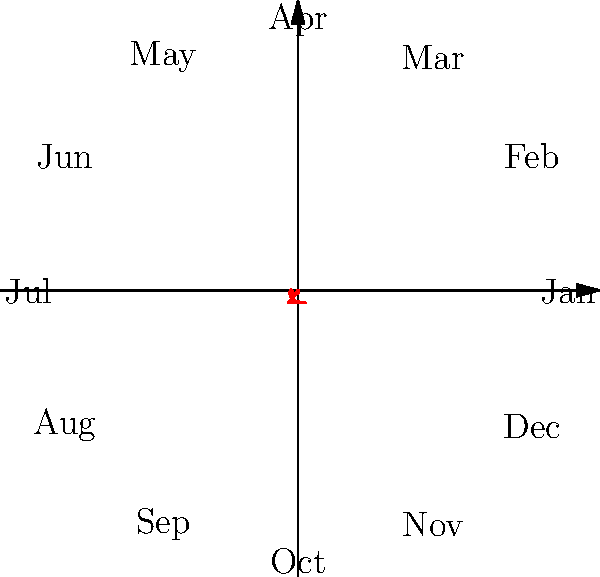The polar rose diagram above represents community event attendance over a year. Which month had the highest attendance, and what strategy might you recommend to replicate this success for other months? To answer this question, we need to analyze the polar rose diagram:

1. The diagram represents community event attendance over 12 months.
2. Each month is represented by a radial line, with the distance from the center indicating attendance numbers.
3. To find the month with the highest attendance, we look for the longest radial line.
4. Observing the diagram, we can see that the longest line points towards the label "Jun", representing June.
5. June has the highest peak, indicating the highest attendance of all months.

Strategies to replicate this success:

1. Analyze the June event: Investigate what made the June event so successful (e.g., type of event, marketing strategies, timing).
2. Seasonal considerations: June often has favorable weather conditions. Consider how to adapt events for other seasons.
3. Community engagement: Reach out to attendees of the June event to understand what attracted them and how to improve future events.
4. Targeted outreach: Use the success of the June event to promote similar events to the same demographic groups.
5. Capacity building: Ensure that resources and staff are available to handle increased attendance in other months.
6. Partnerships: Collaborate with local organizations that were involved in the June event for future events.
7. Feedback loop: Implement a system to gather and act on attendee feedback for continuous improvement.
Answer: June; analyze June's success factors and adapt strategies for other months. 